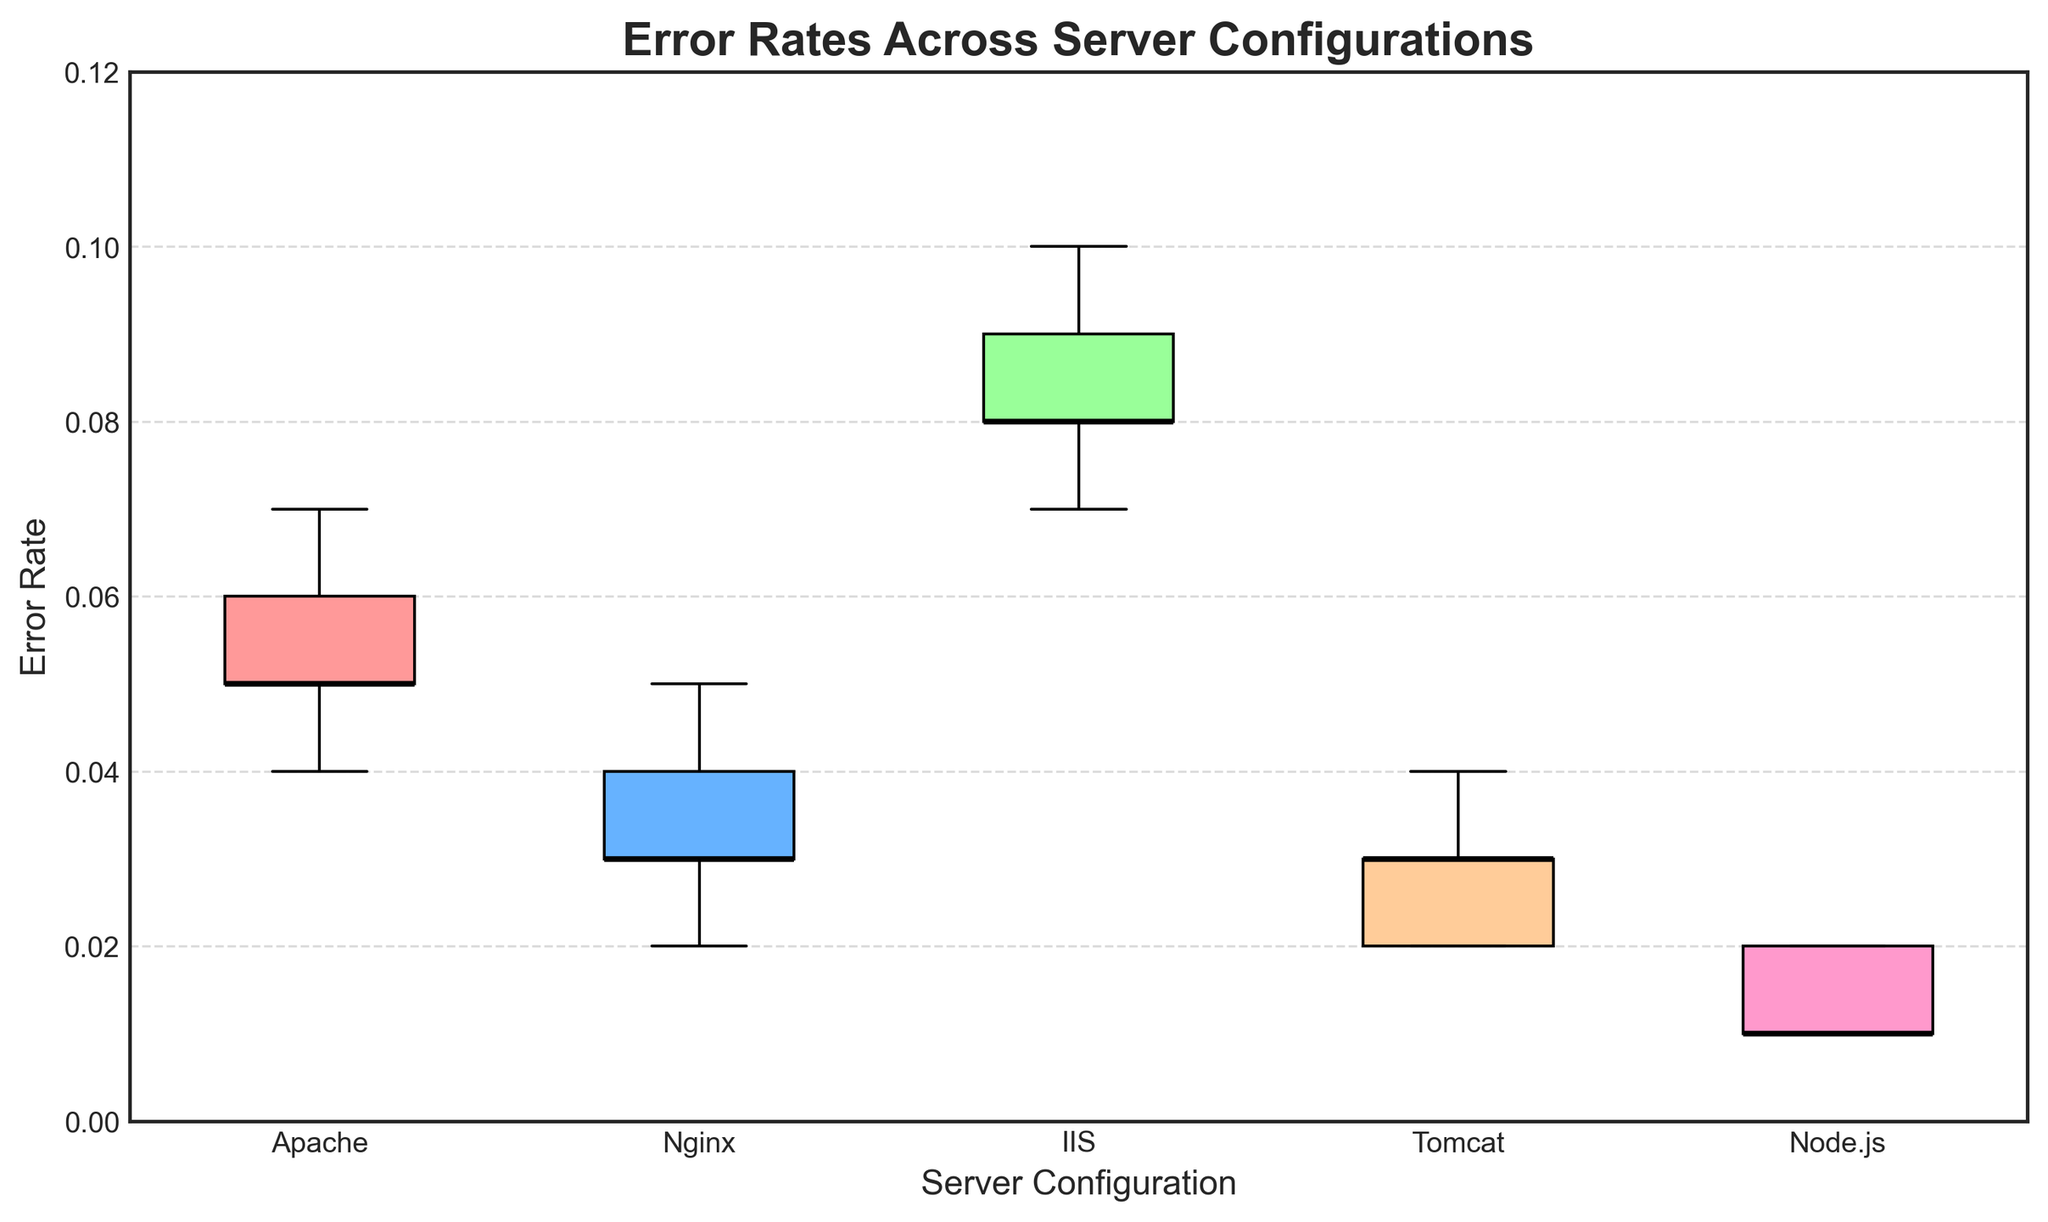what is the median Error Rate for the Nginx configuration? The median Error Rate can be found by looking at the line inside the Nginx box in the box plot. The median is represented by the black line in the middle of the box.
Answer: 0.03 Which server configuration has the highest median Error Rate? The median Error Rate for each server can be identified by looking at the black lines inside each box plot. The server with the highest of these lines has the highest median Error Rate.
Answer: IIS Between Apache and Node.js, which configuration has the larger interquartile range (IQR)? The interquartile range (IQR) is the range between the 25th percentile (bottom of the box) and the 75th percentile (top of the box). By comparing the heights of the boxes for Apache and Node.js, we can determine which one has a larger IQR.
Answer: Apache Is the highest outlier among the server configurations belonging to IIS above 0.1? Outliers are represented by diamond-shaped markers. The highest outlier for IIS can be checked to see if it is above the 0.1 mark on the y-axis.
Answer: No What is the title of the box plot? The title of the box plot is displayed at the top of the figure.
Answer: Error Rates Across Server Configurations Which server configuration shows the lowest error range overall (e.g., difference between the highest and lowest values)? The overall error range is the difference between the minimum and maximum data points in each box plot. By looking at the whiskers or outliers, the smallest range can be identified.
Answer: Node.js How many server configurations have their median Error Rate below 0.035? By observing the black median lines in the box plots and checking if they fall below the 0.035 mark on the y-axis, we can count how many server configurations meet this criterion.
Answer: 3 (Nginx, Tomcat, Node.js) What color is the box representing the Apache configuration? The color of each box differentiates the configurations. The Apache box can be identified by locating its label and noting the color.
Answer: Red Does the Nginx configuration have any outliers? Outliers are marked by red diamond shapes. By looking at the Nginx section of the box plot, we can see if any such markers are present.
Answer: Yes 